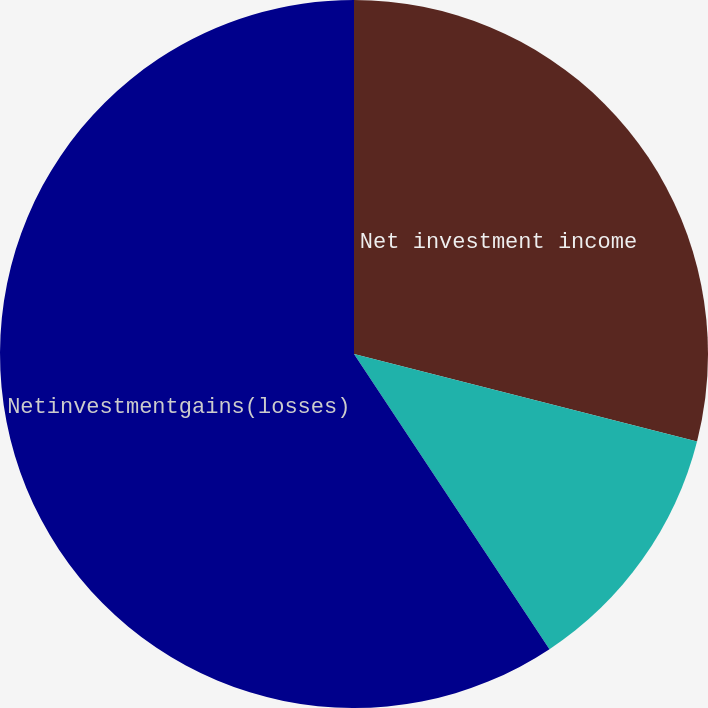Convert chart. <chart><loc_0><loc_0><loc_500><loc_500><pie_chart><fcel>Net investment income<fcel>Unnamed: 1<fcel>Netinvestmentgains(losses)<nl><fcel>28.97%<fcel>11.72%<fcel>59.31%<nl></chart> 